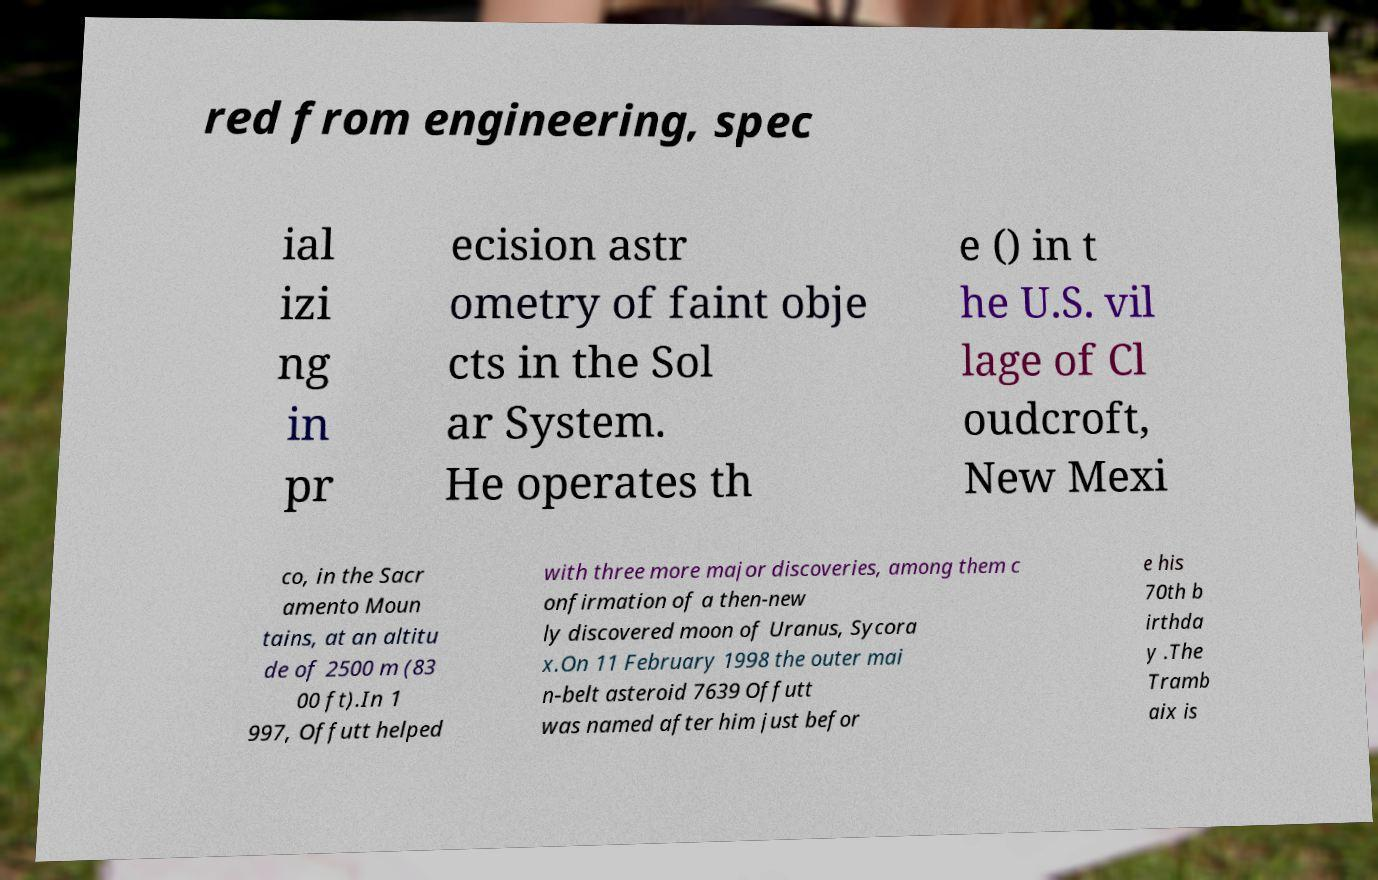Please identify and transcribe the text found in this image. red from engineering, spec ial izi ng in pr ecision astr ometry of faint obje cts in the Sol ar System. He operates th e () in t he U.S. vil lage of Cl oudcroft, New Mexi co, in the Sacr amento Moun tains, at an altitu de of 2500 m (83 00 ft).In 1 997, Offutt helped with three more major discoveries, among them c onfirmation of a then-new ly discovered moon of Uranus, Sycora x.On 11 February 1998 the outer mai n-belt asteroid 7639 Offutt was named after him just befor e his 70th b irthda y .The Tramb aix is 